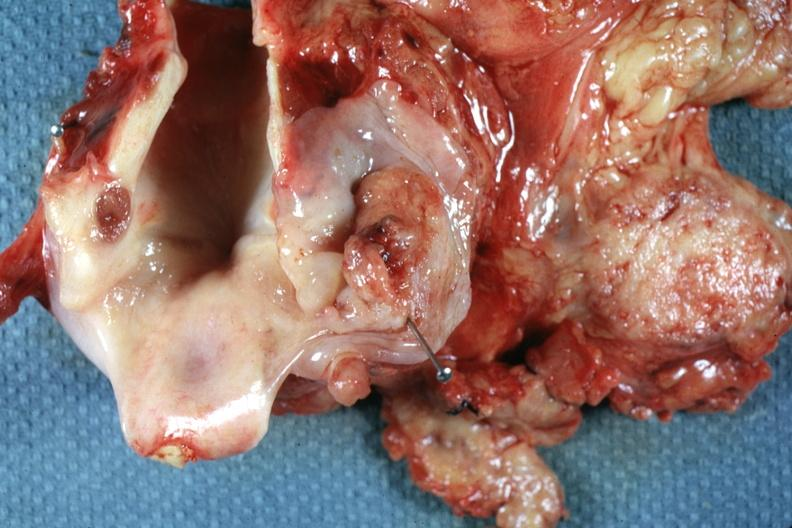s hypopharynx present?
Answer the question using a single word or phrase. Yes 